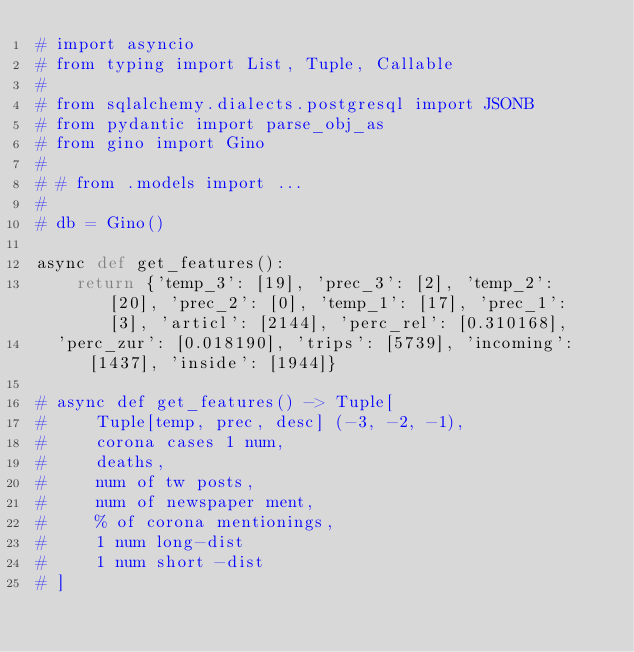<code> <loc_0><loc_0><loc_500><loc_500><_Python_># import asyncio
# from typing import List, Tuple, Callable
#
# from sqlalchemy.dialects.postgresql import JSONB
# from pydantic import parse_obj_as
# from gino import Gino
#
# # from .models import ...
#
# db = Gino()

async def get_features():
    return {'temp_3': [19], 'prec_3': [2], 'temp_2': [20], 'prec_2': [0], 'temp_1': [17], 'prec_1': [3], 'articl': [2144], 'perc_rel': [0.310168],
	'perc_zur': [0.018190], 'trips': [5739], 'incoming': [1437], 'inside': [1944]}

# async def get_features() -> Tuple[
#     Tuple[temp, prec, desc] (-3, -2, -1),
#     corona cases 1 num,
#     deaths,
#     num of tw posts,
#     num of newspaper ment,
#     % of corona mentionings,
#     1 num long-dist
#     1 num short -dist
# ]

</code> 